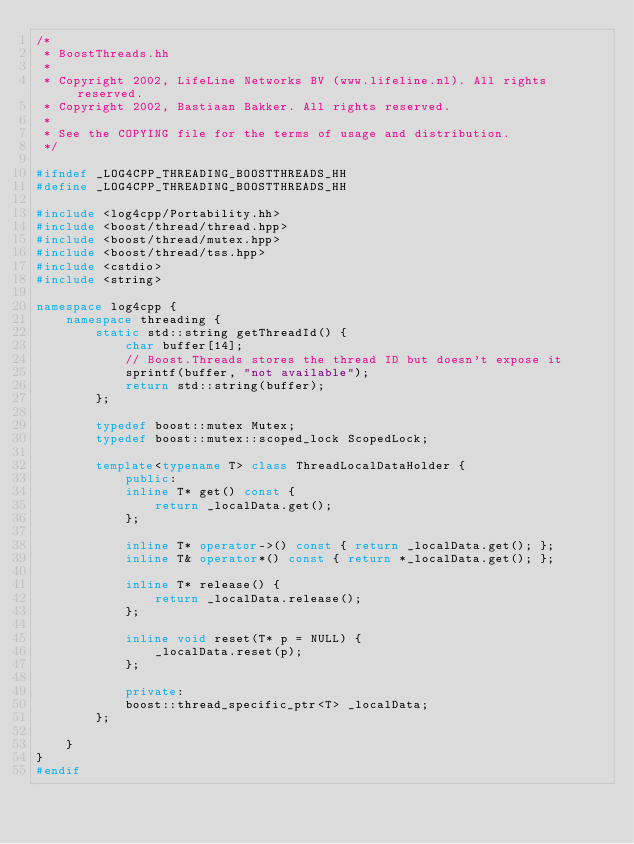<code> <loc_0><loc_0><loc_500><loc_500><_C++_>/*
 * BoostThreads.hh
 *
 * Copyright 2002, LifeLine Networks BV (www.lifeline.nl). All rights reserved.
 * Copyright 2002, Bastiaan Bakker. All rights reserved.
 *
 * See the COPYING file for the terms of usage and distribution.
 */

#ifndef _LOG4CPP_THREADING_BOOSTTHREADS_HH
#define _LOG4CPP_THREADING_BOOSTTHREADS_HH

#include <log4cpp/Portability.hh>
#include <boost/thread/thread.hpp>
#include <boost/thread/mutex.hpp>
#include <boost/thread/tss.hpp>
#include <cstdio>
#include <string>

namespace log4cpp {
    namespace threading {
        static std::string getThreadId() {
            char buffer[14];
            // Boost.Threads stores the thread ID but doesn't expose it
            sprintf(buffer, "not available");
            return std::string(buffer);
        };
        
        typedef boost::mutex Mutex;
        typedef boost::mutex::scoped_lock ScopedLock;

        template<typename T> class ThreadLocalDataHolder {
            public:
            inline T* get() const {
                return _localData.get();
            };

            inline T* operator->() const { return _localData.get(); };
            inline T& operator*() const { return *_localData.get(); };

            inline T* release() {
                return _localData.release();
            };

            inline void reset(T* p = NULL) {
                _localData.reset(p);
            };

            private:
            boost::thread_specific_ptr<T> _localData;
        };

    }
}
#endif
</code> 